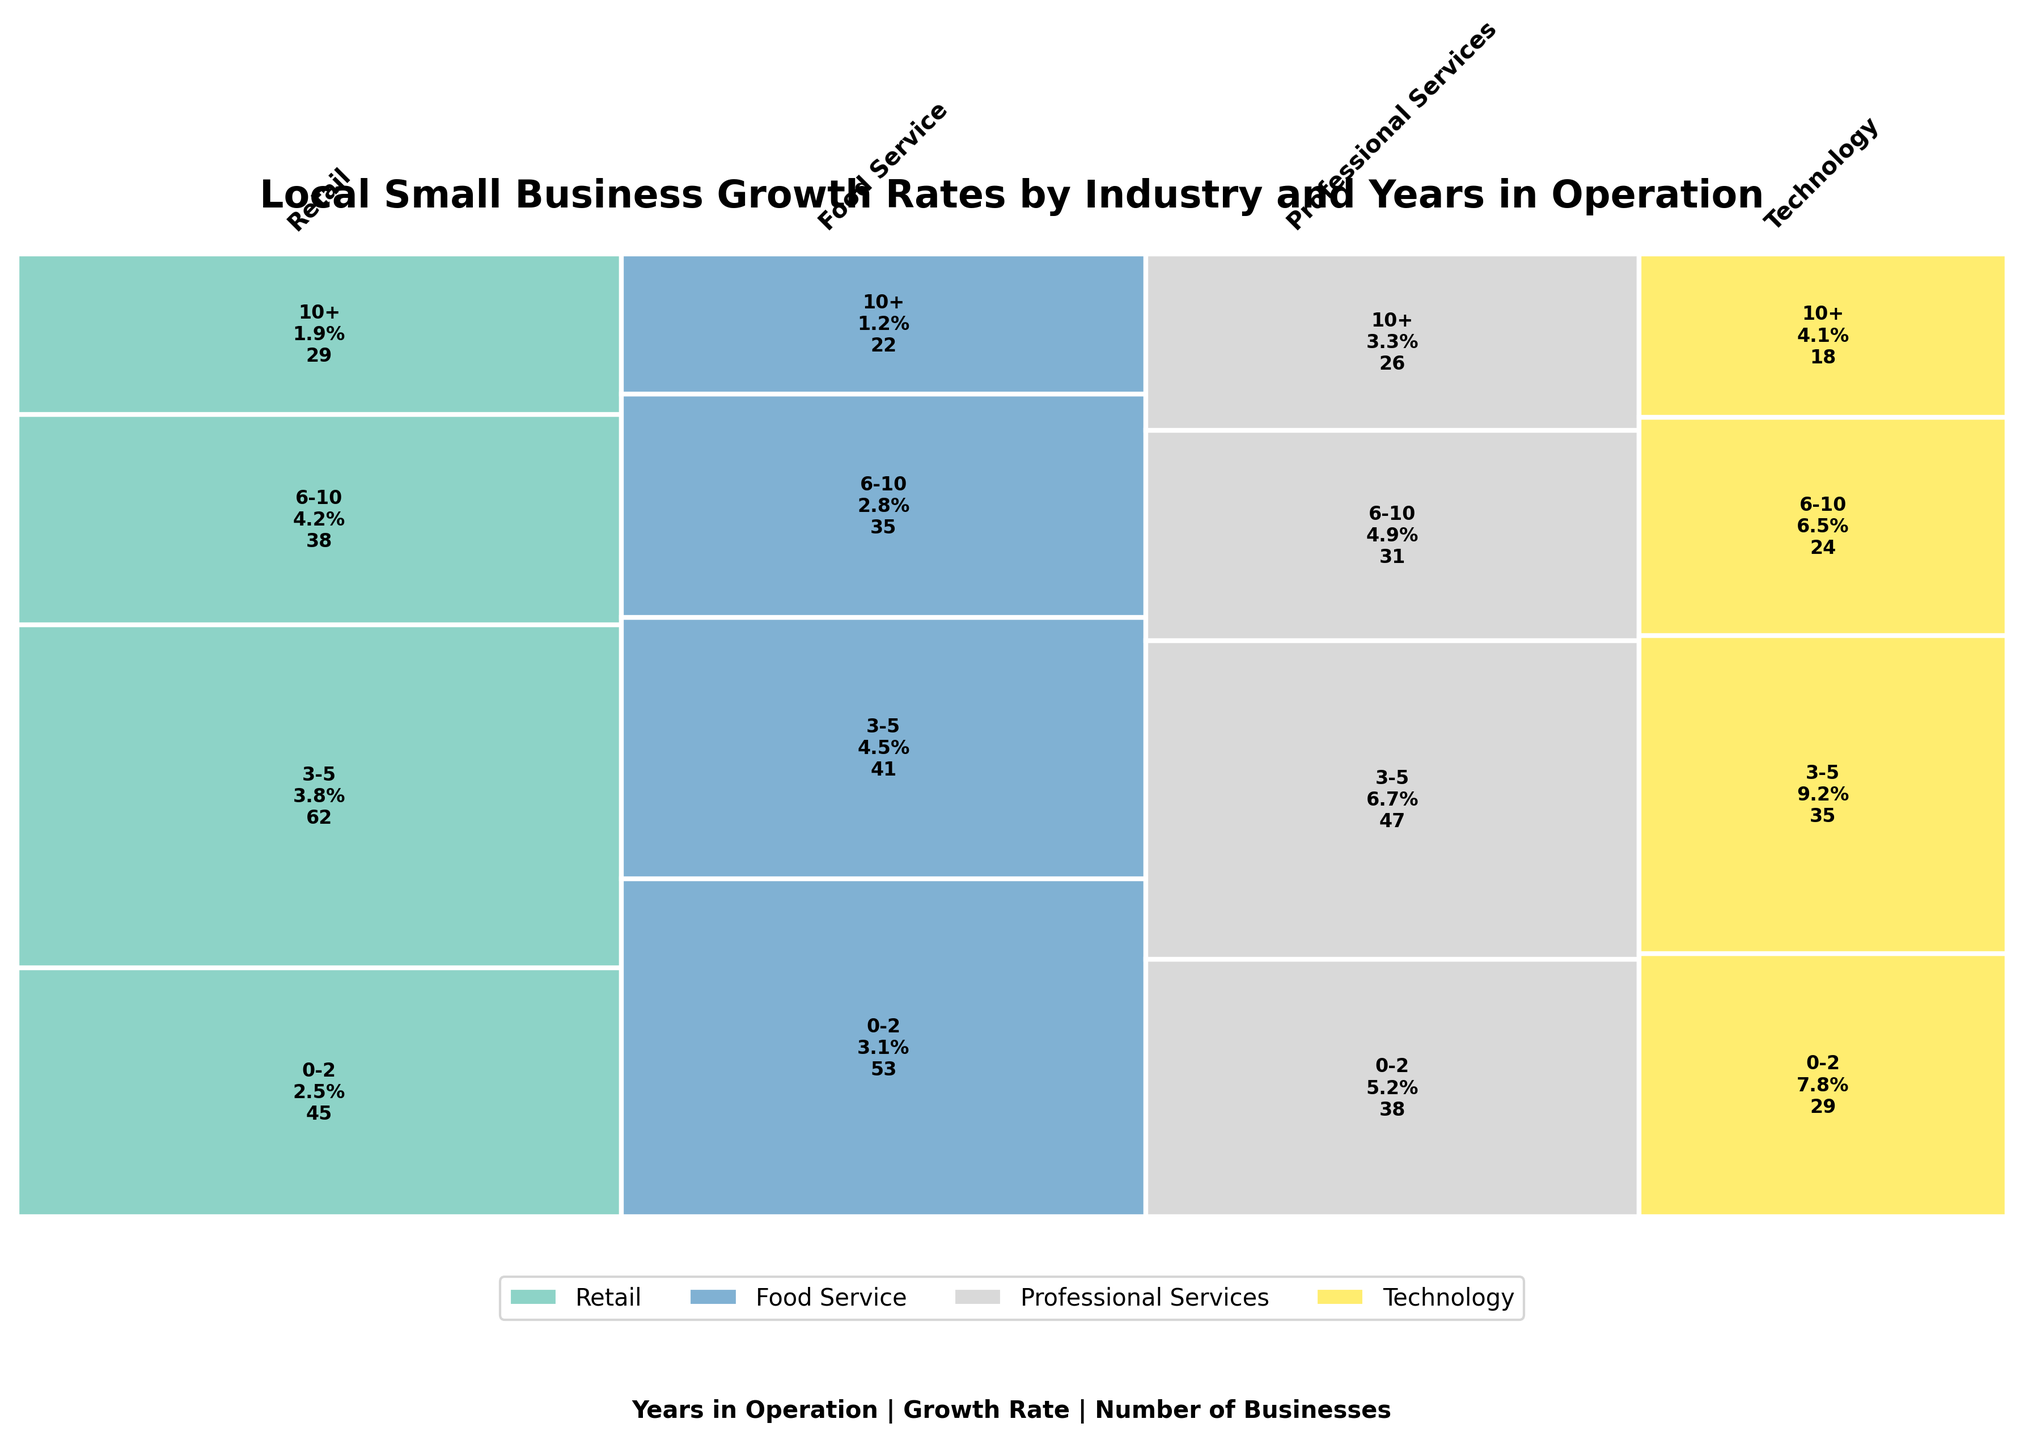What is the title of the plot? The title is usually located at the top of the figure. In this case, the title describes what the plot is about: "Local Small Business Growth Rates by Industry and Years in Operation".
Answer: Local Small Business Growth Rates by Industry and Years in Operation Which industry has the highest growth rate for businesses in operation for 3-5 years? For this question, we locate the different growth rates for businesses operating for 3-5 years in each industry and compare them. Technology has a growth rate of 9.2%, which is the highest among Retail (3.8%), Food Service (4.5%), and Professional Services (6.7%).
Answer: Technology How many businesses in the Food Service industry have been operating for 0-2 years? We look at the Food Service section and identify the '0-2 years' label, which shows the number of businesses. The plot shows that there are 53 businesses.
Answer: 53 What is the overall trend of growth rates for businesses as they operate longer across all industries? By observing the growth rates across all industries for different years, we notice that the growth rate generally decreases as the years in operation increase. For instance, in Technology, growth drops from 7.8% (0-2 years) to 4.1% (10+ years).
Answer: Decreasing Which industry has the largest proportion of long-standing businesses (10+ years)? We compare the widths and heights of the sections representing businesses operating for 10+ years. Retail appears to have the largest proportion based on its visible area in the plot.
Answer: Retail What is the total number of businesses in the Professional Services industry? To find this, we sum the number of businesses across all years in the Professional Services section: 38 (0-2 years) + 47 (3-5 years) + 31 (6-10 years) + 26 (10+ years). This equals 142 businesses.
Answer: 142 Compare the growth rates of Technology and Retail industries for businesses operating for 6-10 years. Which one is higher? Looking at the respective sections for both industries, Technology's growth rate is 6.5%, while Retail's growth rate is 4.2%. Technology has the higher growth rate.
Answer: Technology What information is included within each rectangular segment of the plot? Each rectangular segment includes the 'Years in Operation,' 'Growth Rate,' and 'Number of Businesses' associated with that segment. This information helps to identify and analyze the business conditions for each category visually.
Answer: Years in Operation, Growth Rate, Number of Businesses Considering the entire plot, which industry shows the most variation in growth rates across different years in operation? By examining the variation between the smallest and largest growth rates across industries, Technology shows the most variation with growth rates ranging from 7.8% (0-2 years) to 4.1% (10+ years). The difference is 3.7%.
Answer: Technology 